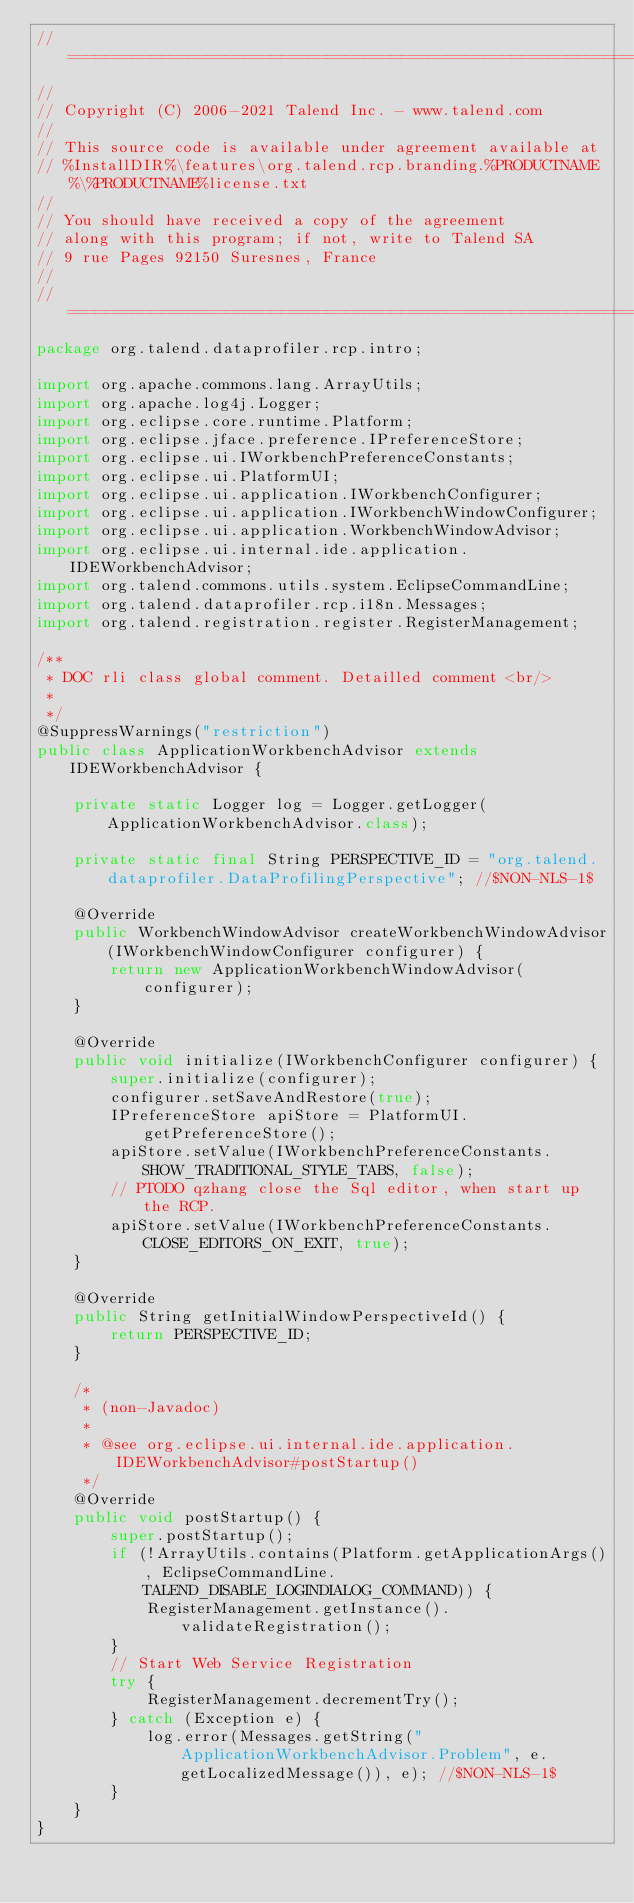Convert code to text. <code><loc_0><loc_0><loc_500><loc_500><_Java_>// ============================================================================
//
// Copyright (C) 2006-2021 Talend Inc. - www.talend.com
//
// This source code is available under agreement available at
// %InstallDIR%\features\org.talend.rcp.branding.%PRODUCTNAME%\%PRODUCTNAME%license.txt
//
// You should have received a copy of the agreement
// along with this program; if not, write to Talend SA
// 9 rue Pages 92150 Suresnes, France
//
// ============================================================================
package org.talend.dataprofiler.rcp.intro;

import org.apache.commons.lang.ArrayUtils;
import org.apache.log4j.Logger;
import org.eclipse.core.runtime.Platform;
import org.eclipse.jface.preference.IPreferenceStore;
import org.eclipse.ui.IWorkbenchPreferenceConstants;
import org.eclipse.ui.PlatformUI;
import org.eclipse.ui.application.IWorkbenchConfigurer;
import org.eclipse.ui.application.IWorkbenchWindowConfigurer;
import org.eclipse.ui.application.WorkbenchWindowAdvisor;
import org.eclipse.ui.internal.ide.application.IDEWorkbenchAdvisor;
import org.talend.commons.utils.system.EclipseCommandLine;
import org.talend.dataprofiler.rcp.i18n.Messages;
import org.talend.registration.register.RegisterManagement;

/**
 * DOC rli class global comment. Detailled comment <br/>
 *
 */
@SuppressWarnings("restriction")
public class ApplicationWorkbenchAdvisor extends IDEWorkbenchAdvisor {

    private static Logger log = Logger.getLogger(ApplicationWorkbenchAdvisor.class);

    private static final String PERSPECTIVE_ID = "org.talend.dataprofiler.DataProfilingPerspective"; //$NON-NLS-1$

    @Override
    public WorkbenchWindowAdvisor createWorkbenchWindowAdvisor(IWorkbenchWindowConfigurer configurer) {
        return new ApplicationWorkbenchWindowAdvisor(configurer);
    }

    @Override
    public void initialize(IWorkbenchConfigurer configurer) {
        super.initialize(configurer);
        configurer.setSaveAndRestore(true);
        IPreferenceStore apiStore = PlatformUI.getPreferenceStore();
        apiStore.setValue(IWorkbenchPreferenceConstants.SHOW_TRADITIONAL_STYLE_TABS, false);
        // PTODO qzhang close the Sql editor, when start up the RCP.
        apiStore.setValue(IWorkbenchPreferenceConstants.CLOSE_EDITORS_ON_EXIT, true);
    }

    @Override
    public String getInitialWindowPerspectiveId() {
        return PERSPECTIVE_ID;
    }

    /*
     * (non-Javadoc)
     *
     * @see org.eclipse.ui.internal.ide.application.IDEWorkbenchAdvisor#postStartup()
     */
    @Override
    public void postStartup() {
        super.postStartup();
        if (!ArrayUtils.contains(Platform.getApplicationArgs(), EclipseCommandLine.TALEND_DISABLE_LOGINDIALOG_COMMAND)) {
            RegisterManagement.getInstance().validateRegistration();
        }
        // Start Web Service Registration
        try {
            RegisterManagement.decrementTry();
        } catch (Exception e) {
            log.error(Messages.getString("ApplicationWorkbenchAdvisor.Problem", e.getLocalizedMessage()), e); //$NON-NLS-1$
        }
    }
}
</code> 